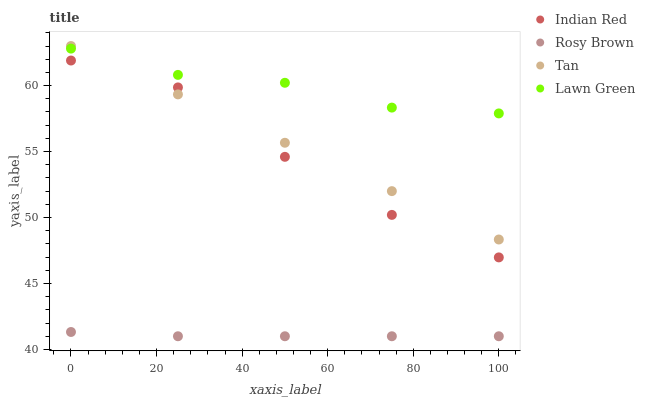Does Rosy Brown have the minimum area under the curve?
Answer yes or no. Yes. Does Lawn Green have the maximum area under the curve?
Answer yes or no. Yes. Does Tan have the minimum area under the curve?
Answer yes or no. No. Does Tan have the maximum area under the curve?
Answer yes or no. No. Is Tan the smoothest?
Answer yes or no. Yes. Is Indian Red the roughest?
Answer yes or no. Yes. Is Rosy Brown the smoothest?
Answer yes or no. No. Is Rosy Brown the roughest?
Answer yes or no. No. Does Rosy Brown have the lowest value?
Answer yes or no. Yes. Does Tan have the lowest value?
Answer yes or no. No. Does Tan have the highest value?
Answer yes or no. Yes. Does Rosy Brown have the highest value?
Answer yes or no. No. Is Rosy Brown less than Indian Red?
Answer yes or no. Yes. Is Tan greater than Rosy Brown?
Answer yes or no. Yes. Does Indian Red intersect Tan?
Answer yes or no. Yes. Is Indian Red less than Tan?
Answer yes or no. No. Is Indian Red greater than Tan?
Answer yes or no. No. Does Rosy Brown intersect Indian Red?
Answer yes or no. No. 